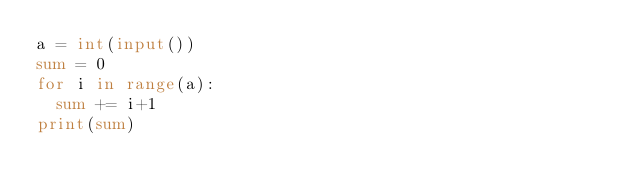Convert code to text. <code><loc_0><loc_0><loc_500><loc_500><_Python_>a = int(input())
sum = 0
for i in range(a):
  sum += i+1
print(sum)</code> 